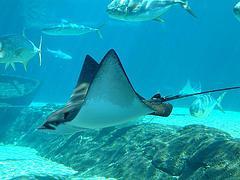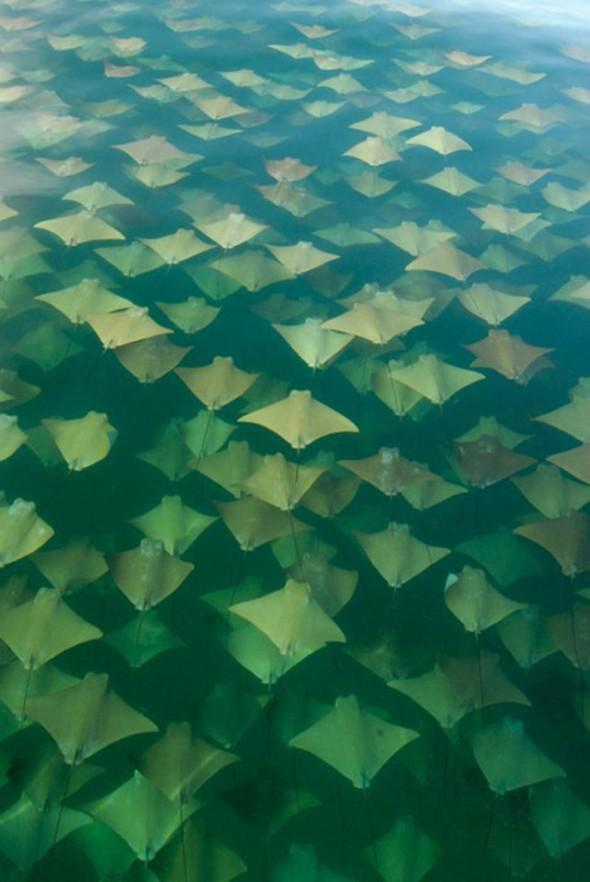The first image is the image on the left, the second image is the image on the right. For the images shown, is this caption "There is exactly one stingray in the image on the left." true? Answer yes or no. Yes. The first image is the image on the left, the second image is the image on the right. Given the left and right images, does the statement "One image contains dozens of stingrays swimming close together." hold true? Answer yes or no. Yes. 